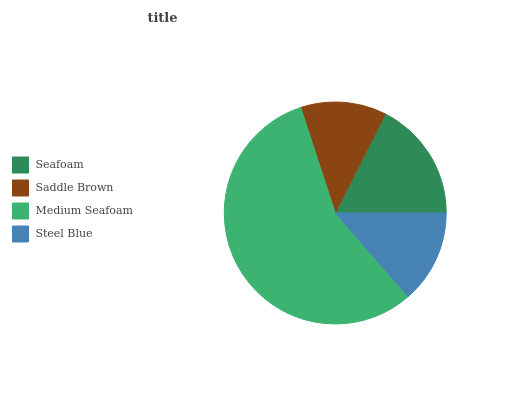Is Saddle Brown the minimum?
Answer yes or no. Yes. Is Medium Seafoam the maximum?
Answer yes or no. Yes. Is Medium Seafoam the minimum?
Answer yes or no. No. Is Saddle Brown the maximum?
Answer yes or no. No. Is Medium Seafoam greater than Saddle Brown?
Answer yes or no. Yes. Is Saddle Brown less than Medium Seafoam?
Answer yes or no. Yes. Is Saddle Brown greater than Medium Seafoam?
Answer yes or no. No. Is Medium Seafoam less than Saddle Brown?
Answer yes or no. No. Is Seafoam the high median?
Answer yes or no. Yes. Is Steel Blue the low median?
Answer yes or no. Yes. Is Saddle Brown the high median?
Answer yes or no. No. Is Seafoam the low median?
Answer yes or no. No. 